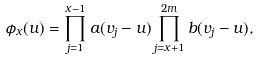<formula> <loc_0><loc_0><loc_500><loc_500>\phi _ { x } ( u ) & = \prod _ { j = 1 } ^ { x - 1 } a ( v _ { j } - u ) \prod _ { j = x + 1 } ^ { 2 m } b ( v _ { j } - u ) ,</formula> 